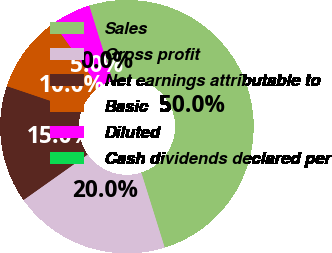Convert chart to OTSL. <chart><loc_0><loc_0><loc_500><loc_500><pie_chart><fcel>Sales<fcel>Gross profit<fcel>Net earnings attributable to<fcel>Basic<fcel>Diluted<fcel>Cash dividends declared per<nl><fcel>50.0%<fcel>20.0%<fcel>15.0%<fcel>10.0%<fcel>5.0%<fcel>0.0%<nl></chart> 